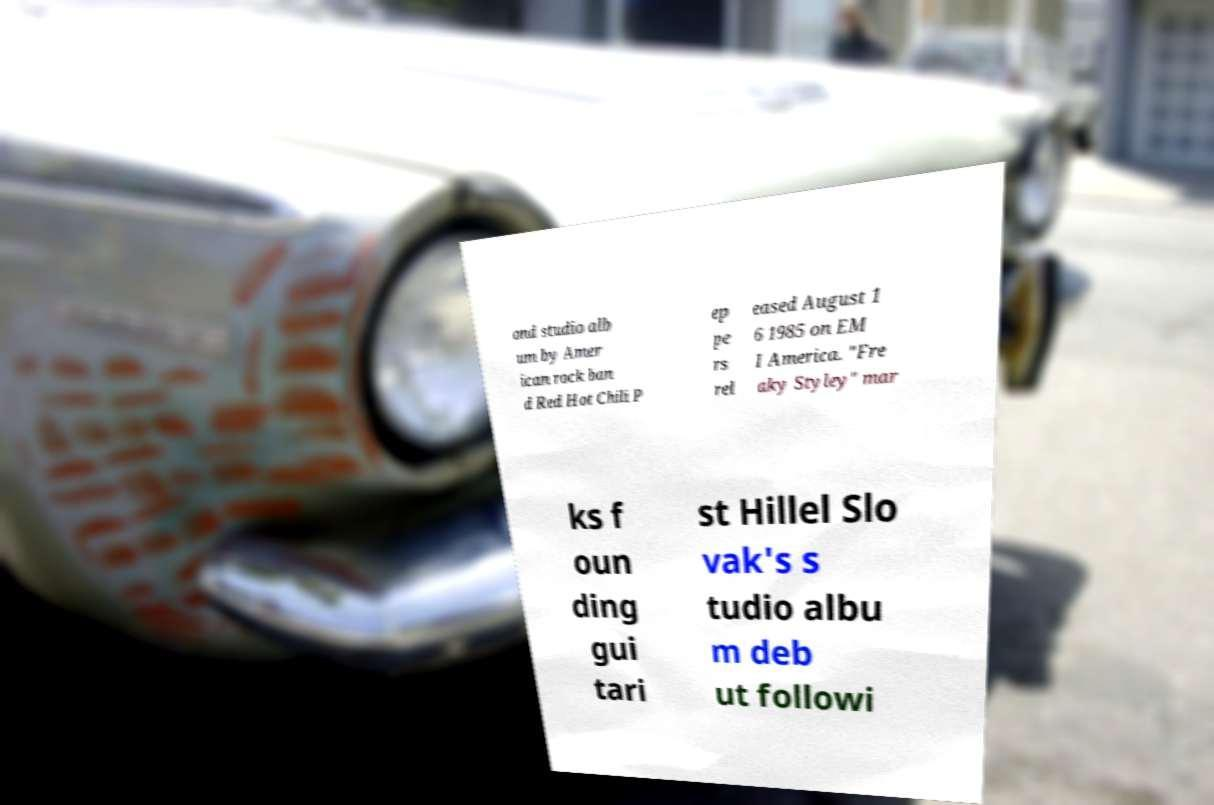Please identify and transcribe the text found in this image. ond studio alb um by Amer ican rock ban d Red Hot Chili P ep pe rs rel eased August 1 6 1985 on EM I America. "Fre aky Styley" mar ks f oun ding gui tari st Hillel Slo vak's s tudio albu m deb ut followi 